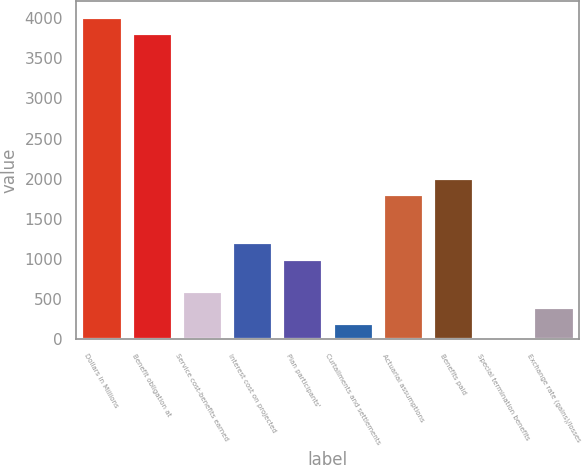<chart> <loc_0><loc_0><loc_500><loc_500><bar_chart><fcel>Dollars in Millions<fcel>Benefit obligation at<fcel>Service cost-benefits earned<fcel>Interest cost on projected<fcel>Plan participants'<fcel>Curtailments and settlements<fcel>Actuarial assumptions<fcel>Benefits paid<fcel>Special termination benefits<fcel>Exchange rate (gains)/losses<nl><fcel>4014<fcel>3813.4<fcel>603.8<fcel>1205.6<fcel>1005<fcel>202.6<fcel>1807.4<fcel>2008<fcel>2<fcel>403.2<nl></chart> 